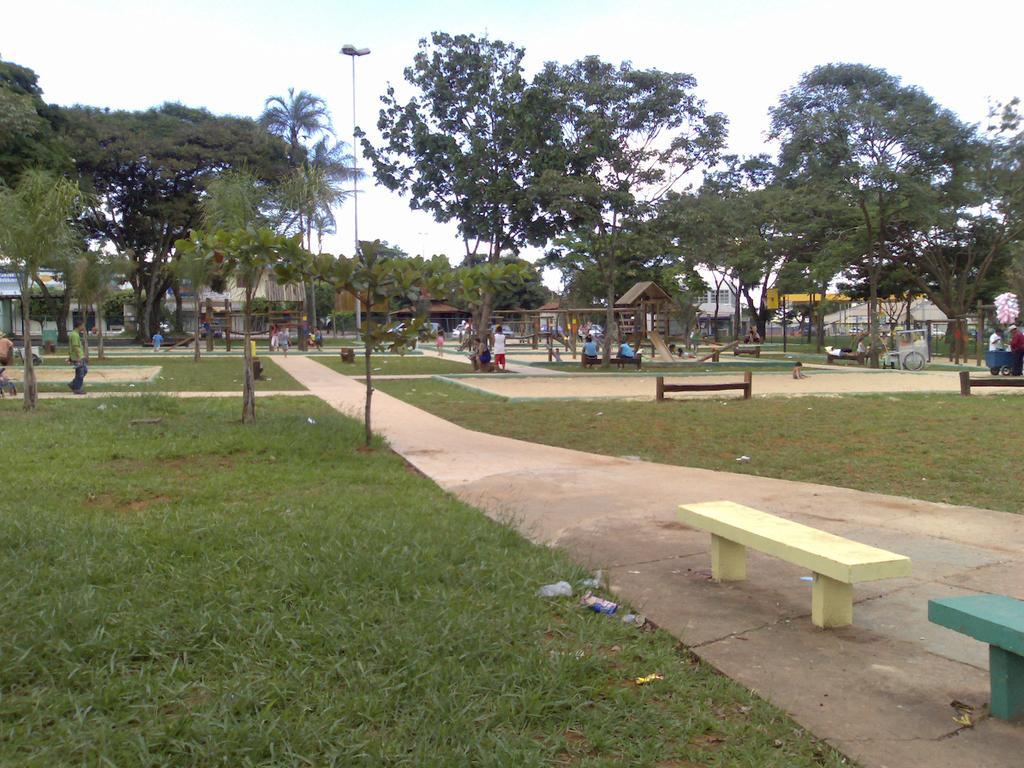Can you describe this image briefly? This picture is clicked outside the city. In this picture, we see many people. At the bottom of the picture, we see grass and benches. In the middle of the picture, we see children are playing seesaw. There are trees, poles and buildings in the background. This picture might be clicked in the park. At the top of the picture, we see the sky. 